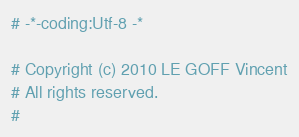<code> <loc_0><loc_0><loc_500><loc_500><_Python_># -*-coding:Utf-8 -*

# Copyright (c) 2010 LE GOFF Vincent
# All rights reserved.
# </code> 